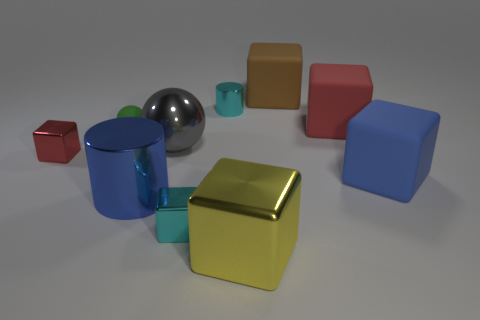How many other objects are there of the same material as the tiny red block?
Offer a very short reply. 5. How many things are either large matte objects that are in front of the brown rubber thing or cyan cubes?
Ensure brevity in your answer.  3. There is a small cyan shiny thing behind the red cube behind the red metal cube; what is its shape?
Your response must be concise. Cylinder. There is a metallic object that is in front of the tiny cyan block; does it have the same shape as the large gray object?
Provide a succinct answer. No. There is a metal cylinder that is behind the red shiny cube; what is its color?
Your response must be concise. Cyan. How many blocks are either gray objects or small metal objects?
Make the answer very short. 2. There is a red object left of the tiny cyan shiny object that is in front of the small cyan cylinder; how big is it?
Keep it short and to the point. Small. Do the large sphere and the rubber thing to the left of the big brown object have the same color?
Offer a very short reply. No. There is a cyan metallic cylinder; how many cyan blocks are behind it?
Make the answer very short. 0. Are there fewer large blue cylinders than tiny blue matte blocks?
Your answer should be very brief. No. 